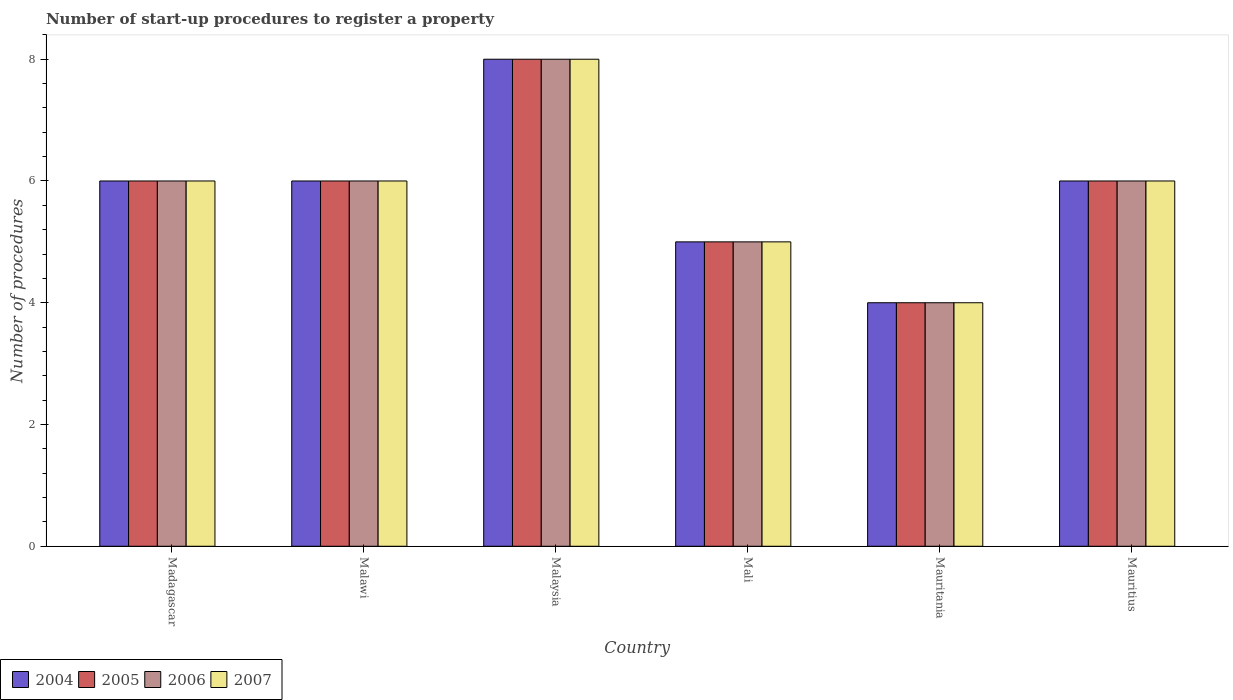How many different coloured bars are there?
Provide a short and direct response. 4. How many groups of bars are there?
Your response must be concise. 6. Are the number of bars per tick equal to the number of legend labels?
Provide a succinct answer. Yes. How many bars are there on the 3rd tick from the left?
Ensure brevity in your answer.  4. How many bars are there on the 5th tick from the right?
Give a very brief answer. 4. What is the label of the 5th group of bars from the left?
Provide a short and direct response. Mauritania. What is the number of procedures required to register a property in 2007 in Mali?
Your answer should be very brief. 5. Across all countries, what is the maximum number of procedures required to register a property in 2004?
Your response must be concise. 8. Across all countries, what is the minimum number of procedures required to register a property in 2006?
Ensure brevity in your answer.  4. In which country was the number of procedures required to register a property in 2006 maximum?
Ensure brevity in your answer.  Malaysia. In which country was the number of procedures required to register a property in 2004 minimum?
Provide a succinct answer. Mauritania. What is the total number of procedures required to register a property in 2006 in the graph?
Give a very brief answer. 35. What is the difference between the number of procedures required to register a property in 2005 in Malaysia and that in Mauritius?
Provide a short and direct response. 2. What is the difference between the number of procedures required to register a property in 2004 in Mauritania and the number of procedures required to register a property in 2006 in Malaysia?
Your answer should be compact. -4. What is the average number of procedures required to register a property in 2007 per country?
Provide a succinct answer. 5.83. What is the difference between the number of procedures required to register a property of/in 2007 and number of procedures required to register a property of/in 2005 in Malaysia?
Give a very brief answer. 0. Is the number of procedures required to register a property in 2005 in Mali less than that in Mauritania?
Offer a very short reply. No. Is the difference between the number of procedures required to register a property in 2007 in Malawi and Malaysia greater than the difference between the number of procedures required to register a property in 2005 in Malawi and Malaysia?
Your answer should be very brief. No. What is the difference between the highest and the second highest number of procedures required to register a property in 2007?
Keep it short and to the point. 2. Is the sum of the number of procedures required to register a property in 2006 in Mali and Mauritania greater than the maximum number of procedures required to register a property in 2004 across all countries?
Keep it short and to the point. Yes. What does the 1st bar from the left in Mauritius represents?
Offer a very short reply. 2004. What does the 1st bar from the right in Madagascar represents?
Your answer should be very brief. 2007. Are all the bars in the graph horizontal?
Offer a very short reply. No. How many countries are there in the graph?
Provide a succinct answer. 6. What is the difference between two consecutive major ticks on the Y-axis?
Your answer should be compact. 2. Are the values on the major ticks of Y-axis written in scientific E-notation?
Make the answer very short. No. Does the graph contain any zero values?
Provide a succinct answer. No. Does the graph contain grids?
Offer a terse response. No. How many legend labels are there?
Your response must be concise. 4. How are the legend labels stacked?
Give a very brief answer. Horizontal. What is the title of the graph?
Offer a very short reply. Number of start-up procedures to register a property. Does "2007" appear as one of the legend labels in the graph?
Offer a terse response. Yes. What is the label or title of the X-axis?
Ensure brevity in your answer.  Country. What is the label or title of the Y-axis?
Ensure brevity in your answer.  Number of procedures. What is the Number of procedures in 2004 in Madagascar?
Give a very brief answer. 6. What is the Number of procedures in 2005 in Madagascar?
Offer a very short reply. 6. What is the Number of procedures of 2006 in Madagascar?
Offer a very short reply. 6. What is the Number of procedures of 2004 in Malaysia?
Offer a very short reply. 8. What is the Number of procedures in 2006 in Malaysia?
Provide a succinct answer. 8. What is the Number of procedures in 2005 in Mali?
Your answer should be compact. 5. What is the Number of procedures in 2006 in Mali?
Your answer should be compact. 5. What is the Number of procedures in 2006 in Mauritania?
Give a very brief answer. 4. What is the Number of procedures of 2007 in Mauritania?
Your answer should be very brief. 4. What is the Number of procedures in 2004 in Mauritius?
Offer a terse response. 6. What is the Number of procedures of 2005 in Mauritius?
Keep it short and to the point. 6. Across all countries, what is the maximum Number of procedures in 2004?
Ensure brevity in your answer.  8. Across all countries, what is the maximum Number of procedures in 2005?
Your answer should be compact. 8. Across all countries, what is the minimum Number of procedures in 2005?
Provide a succinct answer. 4. Across all countries, what is the minimum Number of procedures of 2006?
Provide a short and direct response. 4. What is the total Number of procedures in 2004 in the graph?
Ensure brevity in your answer.  35. What is the total Number of procedures of 2005 in the graph?
Provide a short and direct response. 35. What is the total Number of procedures in 2006 in the graph?
Keep it short and to the point. 35. What is the total Number of procedures in 2007 in the graph?
Keep it short and to the point. 35. What is the difference between the Number of procedures of 2004 in Madagascar and that in Malawi?
Your response must be concise. 0. What is the difference between the Number of procedures of 2004 in Madagascar and that in Malaysia?
Make the answer very short. -2. What is the difference between the Number of procedures of 2005 in Madagascar and that in Malaysia?
Ensure brevity in your answer.  -2. What is the difference between the Number of procedures of 2006 in Madagascar and that in Malaysia?
Provide a succinct answer. -2. What is the difference between the Number of procedures in 2007 in Madagascar and that in Malaysia?
Offer a very short reply. -2. What is the difference between the Number of procedures of 2004 in Madagascar and that in Mali?
Ensure brevity in your answer.  1. What is the difference between the Number of procedures in 2006 in Madagascar and that in Mali?
Provide a succinct answer. 1. What is the difference between the Number of procedures in 2005 in Madagascar and that in Mauritania?
Offer a very short reply. 2. What is the difference between the Number of procedures of 2006 in Madagascar and that in Mauritania?
Give a very brief answer. 2. What is the difference between the Number of procedures of 2007 in Madagascar and that in Mauritania?
Provide a succinct answer. 2. What is the difference between the Number of procedures in 2005 in Madagascar and that in Mauritius?
Your response must be concise. 0. What is the difference between the Number of procedures of 2007 in Madagascar and that in Mauritius?
Your response must be concise. 0. What is the difference between the Number of procedures in 2004 in Malawi and that in Malaysia?
Your response must be concise. -2. What is the difference between the Number of procedures in 2007 in Malawi and that in Malaysia?
Give a very brief answer. -2. What is the difference between the Number of procedures in 2004 in Malawi and that in Mauritania?
Keep it short and to the point. 2. What is the difference between the Number of procedures of 2005 in Malawi and that in Mauritania?
Give a very brief answer. 2. What is the difference between the Number of procedures of 2006 in Malawi and that in Mauritania?
Offer a very short reply. 2. What is the difference between the Number of procedures in 2004 in Malawi and that in Mauritius?
Give a very brief answer. 0. What is the difference between the Number of procedures of 2007 in Malawi and that in Mauritius?
Your answer should be compact. 0. What is the difference between the Number of procedures in 2005 in Malaysia and that in Mali?
Your answer should be compact. 3. What is the difference between the Number of procedures of 2006 in Malaysia and that in Mali?
Offer a terse response. 3. What is the difference between the Number of procedures in 2005 in Malaysia and that in Mauritania?
Provide a succinct answer. 4. What is the difference between the Number of procedures in 2006 in Malaysia and that in Mauritania?
Provide a succinct answer. 4. What is the difference between the Number of procedures in 2007 in Malaysia and that in Mauritania?
Your answer should be compact. 4. What is the difference between the Number of procedures of 2004 in Malaysia and that in Mauritius?
Offer a very short reply. 2. What is the difference between the Number of procedures in 2005 in Malaysia and that in Mauritius?
Your response must be concise. 2. What is the difference between the Number of procedures in 2004 in Mali and that in Mauritania?
Give a very brief answer. 1. What is the difference between the Number of procedures of 2005 in Mali and that in Mauritania?
Give a very brief answer. 1. What is the difference between the Number of procedures of 2006 in Mali and that in Mauritania?
Keep it short and to the point. 1. What is the difference between the Number of procedures in 2007 in Mali and that in Mauritania?
Ensure brevity in your answer.  1. What is the difference between the Number of procedures in 2004 in Mali and that in Mauritius?
Offer a terse response. -1. What is the difference between the Number of procedures of 2006 in Mali and that in Mauritius?
Your response must be concise. -1. What is the difference between the Number of procedures in 2007 in Mali and that in Mauritius?
Provide a succinct answer. -1. What is the difference between the Number of procedures in 2004 in Mauritania and that in Mauritius?
Your answer should be very brief. -2. What is the difference between the Number of procedures of 2006 in Mauritania and that in Mauritius?
Ensure brevity in your answer.  -2. What is the difference between the Number of procedures in 2007 in Mauritania and that in Mauritius?
Ensure brevity in your answer.  -2. What is the difference between the Number of procedures of 2004 in Madagascar and the Number of procedures of 2005 in Malawi?
Offer a terse response. 0. What is the difference between the Number of procedures in 2004 in Madagascar and the Number of procedures in 2006 in Malawi?
Provide a succinct answer. 0. What is the difference between the Number of procedures in 2005 in Madagascar and the Number of procedures in 2006 in Malawi?
Keep it short and to the point. 0. What is the difference between the Number of procedures in 2005 in Madagascar and the Number of procedures in 2007 in Malawi?
Ensure brevity in your answer.  0. What is the difference between the Number of procedures in 2004 in Madagascar and the Number of procedures in 2005 in Malaysia?
Your answer should be very brief. -2. What is the difference between the Number of procedures of 2004 in Madagascar and the Number of procedures of 2006 in Malaysia?
Your answer should be compact. -2. What is the difference between the Number of procedures in 2004 in Madagascar and the Number of procedures in 2007 in Malaysia?
Ensure brevity in your answer.  -2. What is the difference between the Number of procedures of 2005 in Madagascar and the Number of procedures of 2006 in Malaysia?
Ensure brevity in your answer.  -2. What is the difference between the Number of procedures in 2006 in Madagascar and the Number of procedures in 2007 in Malaysia?
Your answer should be very brief. -2. What is the difference between the Number of procedures in 2004 in Madagascar and the Number of procedures in 2005 in Mali?
Make the answer very short. 1. What is the difference between the Number of procedures of 2004 in Madagascar and the Number of procedures of 2007 in Mali?
Provide a short and direct response. 1. What is the difference between the Number of procedures in 2005 in Madagascar and the Number of procedures in 2006 in Mali?
Your response must be concise. 1. What is the difference between the Number of procedures of 2005 in Madagascar and the Number of procedures of 2007 in Mali?
Provide a succinct answer. 1. What is the difference between the Number of procedures in 2004 in Madagascar and the Number of procedures in 2006 in Mauritania?
Provide a short and direct response. 2. What is the difference between the Number of procedures in 2004 in Madagascar and the Number of procedures in 2007 in Mauritania?
Ensure brevity in your answer.  2. What is the difference between the Number of procedures of 2005 in Madagascar and the Number of procedures of 2006 in Mauritania?
Provide a short and direct response. 2. What is the difference between the Number of procedures of 2006 in Madagascar and the Number of procedures of 2007 in Mauritania?
Provide a succinct answer. 2. What is the difference between the Number of procedures in 2004 in Madagascar and the Number of procedures in 2005 in Mauritius?
Offer a very short reply. 0. What is the difference between the Number of procedures of 2004 in Madagascar and the Number of procedures of 2006 in Mauritius?
Your answer should be compact. 0. What is the difference between the Number of procedures of 2004 in Madagascar and the Number of procedures of 2007 in Mauritius?
Your answer should be very brief. 0. What is the difference between the Number of procedures of 2005 in Madagascar and the Number of procedures of 2006 in Mauritius?
Your response must be concise. 0. What is the difference between the Number of procedures in 2005 in Madagascar and the Number of procedures in 2007 in Mauritius?
Your response must be concise. 0. What is the difference between the Number of procedures in 2006 in Madagascar and the Number of procedures in 2007 in Mauritius?
Keep it short and to the point. 0. What is the difference between the Number of procedures in 2004 in Malawi and the Number of procedures in 2007 in Malaysia?
Make the answer very short. -2. What is the difference between the Number of procedures of 2005 in Malawi and the Number of procedures of 2006 in Malaysia?
Give a very brief answer. -2. What is the difference between the Number of procedures of 2005 in Malawi and the Number of procedures of 2007 in Malaysia?
Offer a very short reply. -2. What is the difference between the Number of procedures in 2006 in Malawi and the Number of procedures in 2007 in Malaysia?
Ensure brevity in your answer.  -2. What is the difference between the Number of procedures in 2004 in Malawi and the Number of procedures in 2006 in Mali?
Your answer should be very brief. 1. What is the difference between the Number of procedures of 2004 in Malawi and the Number of procedures of 2007 in Mali?
Give a very brief answer. 1. What is the difference between the Number of procedures of 2006 in Malawi and the Number of procedures of 2007 in Mali?
Your response must be concise. 1. What is the difference between the Number of procedures in 2004 in Malawi and the Number of procedures in 2005 in Mauritania?
Your answer should be compact. 2. What is the difference between the Number of procedures in 2005 in Malawi and the Number of procedures in 2006 in Mauritania?
Your answer should be compact. 2. What is the difference between the Number of procedures in 2006 in Malawi and the Number of procedures in 2007 in Mauritania?
Your answer should be compact. 2. What is the difference between the Number of procedures in 2004 in Malawi and the Number of procedures in 2005 in Mauritius?
Offer a very short reply. 0. What is the difference between the Number of procedures in 2004 in Malawi and the Number of procedures in 2006 in Mauritius?
Your answer should be very brief. 0. What is the difference between the Number of procedures of 2004 in Malawi and the Number of procedures of 2007 in Mauritius?
Make the answer very short. 0. What is the difference between the Number of procedures of 2006 in Malawi and the Number of procedures of 2007 in Mauritius?
Offer a very short reply. 0. What is the difference between the Number of procedures in 2004 in Malaysia and the Number of procedures in 2005 in Mauritania?
Give a very brief answer. 4. What is the difference between the Number of procedures in 2004 in Malaysia and the Number of procedures in 2006 in Mauritania?
Make the answer very short. 4. What is the difference between the Number of procedures of 2005 in Malaysia and the Number of procedures of 2007 in Mauritania?
Offer a very short reply. 4. What is the difference between the Number of procedures of 2006 in Malaysia and the Number of procedures of 2007 in Mauritania?
Keep it short and to the point. 4. What is the difference between the Number of procedures of 2004 in Malaysia and the Number of procedures of 2005 in Mauritius?
Your answer should be compact. 2. What is the difference between the Number of procedures of 2004 in Malaysia and the Number of procedures of 2007 in Mauritius?
Provide a short and direct response. 2. What is the difference between the Number of procedures of 2005 in Malaysia and the Number of procedures of 2007 in Mauritius?
Provide a succinct answer. 2. What is the difference between the Number of procedures of 2005 in Mali and the Number of procedures of 2007 in Mauritania?
Ensure brevity in your answer.  1. What is the difference between the Number of procedures of 2006 in Mali and the Number of procedures of 2007 in Mauritania?
Make the answer very short. 1. What is the difference between the Number of procedures in 2005 in Mali and the Number of procedures in 2006 in Mauritius?
Keep it short and to the point. -1. What is the difference between the Number of procedures of 2005 in Mali and the Number of procedures of 2007 in Mauritius?
Provide a succinct answer. -1. What is the difference between the Number of procedures in 2004 in Mauritania and the Number of procedures in 2006 in Mauritius?
Keep it short and to the point. -2. What is the difference between the Number of procedures in 2005 in Mauritania and the Number of procedures in 2006 in Mauritius?
Ensure brevity in your answer.  -2. What is the difference between the Number of procedures of 2006 in Mauritania and the Number of procedures of 2007 in Mauritius?
Keep it short and to the point. -2. What is the average Number of procedures of 2004 per country?
Offer a very short reply. 5.83. What is the average Number of procedures of 2005 per country?
Your response must be concise. 5.83. What is the average Number of procedures in 2006 per country?
Provide a succinct answer. 5.83. What is the average Number of procedures in 2007 per country?
Ensure brevity in your answer.  5.83. What is the difference between the Number of procedures in 2005 and Number of procedures in 2006 in Madagascar?
Ensure brevity in your answer.  0. What is the difference between the Number of procedures of 2005 and Number of procedures of 2007 in Madagascar?
Ensure brevity in your answer.  0. What is the difference between the Number of procedures of 2006 and Number of procedures of 2007 in Madagascar?
Give a very brief answer. 0. What is the difference between the Number of procedures of 2004 and Number of procedures of 2006 in Malawi?
Offer a terse response. 0. What is the difference between the Number of procedures of 2005 and Number of procedures of 2007 in Malawi?
Give a very brief answer. 0. What is the difference between the Number of procedures of 2004 and Number of procedures of 2007 in Malaysia?
Ensure brevity in your answer.  0. What is the difference between the Number of procedures of 2005 and Number of procedures of 2006 in Malaysia?
Provide a short and direct response. 0. What is the difference between the Number of procedures of 2004 and Number of procedures of 2005 in Mali?
Provide a short and direct response. 0. What is the difference between the Number of procedures of 2004 and Number of procedures of 2006 in Mali?
Provide a succinct answer. 0. What is the difference between the Number of procedures in 2004 and Number of procedures in 2007 in Mali?
Offer a terse response. 0. What is the difference between the Number of procedures in 2004 and Number of procedures in 2005 in Mauritania?
Provide a succinct answer. 0. What is the difference between the Number of procedures in 2005 and Number of procedures in 2006 in Mauritania?
Keep it short and to the point. 0. What is the difference between the Number of procedures of 2005 and Number of procedures of 2007 in Mauritania?
Ensure brevity in your answer.  0. What is the difference between the Number of procedures in 2006 and Number of procedures in 2007 in Mauritania?
Make the answer very short. 0. What is the difference between the Number of procedures of 2005 and Number of procedures of 2006 in Mauritius?
Your answer should be compact. 0. What is the difference between the Number of procedures in 2005 and Number of procedures in 2007 in Mauritius?
Make the answer very short. 0. What is the ratio of the Number of procedures in 2004 in Madagascar to that in Malawi?
Make the answer very short. 1. What is the ratio of the Number of procedures of 2005 in Madagascar to that in Malawi?
Ensure brevity in your answer.  1. What is the ratio of the Number of procedures of 2007 in Madagascar to that in Malawi?
Your response must be concise. 1. What is the ratio of the Number of procedures of 2004 in Madagascar to that in Malaysia?
Your answer should be compact. 0.75. What is the ratio of the Number of procedures in 2006 in Madagascar to that in Malaysia?
Offer a terse response. 0.75. What is the ratio of the Number of procedures of 2007 in Madagascar to that in Malaysia?
Offer a terse response. 0.75. What is the ratio of the Number of procedures of 2004 in Madagascar to that in Mauritania?
Your answer should be very brief. 1.5. What is the ratio of the Number of procedures in 2006 in Madagascar to that in Mauritania?
Offer a very short reply. 1.5. What is the ratio of the Number of procedures in 2007 in Madagascar to that in Mauritania?
Your response must be concise. 1.5. What is the ratio of the Number of procedures in 2004 in Madagascar to that in Mauritius?
Your response must be concise. 1. What is the ratio of the Number of procedures in 2004 in Malawi to that in Malaysia?
Offer a very short reply. 0.75. What is the ratio of the Number of procedures of 2006 in Malawi to that in Malaysia?
Your answer should be compact. 0.75. What is the ratio of the Number of procedures of 2005 in Malawi to that in Mali?
Make the answer very short. 1.2. What is the ratio of the Number of procedures in 2005 in Malawi to that in Mauritania?
Your answer should be compact. 1.5. What is the ratio of the Number of procedures of 2004 in Malawi to that in Mauritius?
Your response must be concise. 1. What is the ratio of the Number of procedures of 2005 in Malawi to that in Mauritius?
Your answer should be compact. 1. What is the ratio of the Number of procedures in 2006 in Malawi to that in Mauritius?
Your response must be concise. 1. What is the ratio of the Number of procedures of 2007 in Malawi to that in Mauritius?
Ensure brevity in your answer.  1. What is the ratio of the Number of procedures in 2007 in Malaysia to that in Mali?
Offer a terse response. 1.6. What is the ratio of the Number of procedures in 2004 in Malaysia to that in Mauritius?
Provide a succinct answer. 1.33. What is the ratio of the Number of procedures of 2005 in Malaysia to that in Mauritius?
Provide a short and direct response. 1.33. What is the ratio of the Number of procedures of 2004 in Mali to that in Mauritania?
Your answer should be compact. 1.25. What is the ratio of the Number of procedures of 2005 in Mali to that in Mauritius?
Provide a succinct answer. 0.83. What is the ratio of the Number of procedures in 2006 in Mali to that in Mauritius?
Your answer should be very brief. 0.83. What is the difference between the highest and the second highest Number of procedures in 2005?
Ensure brevity in your answer.  2. What is the difference between the highest and the second highest Number of procedures of 2006?
Keep it short and to the point. 2. What is the difference between the highest and the second highest Number of procedures of 2007?
Make the answer very short. 2. What is the difference between the highest and the lowest Number of procedures of 2004?
Offer a very short reply. 4. What is the difference between the highest and the lowest Number of procedures of 2005?
Offer a terse response. 4. What is the difference between the highest and the lowest Number of procedures of 2007?
Provide a succinct answer. 4. 